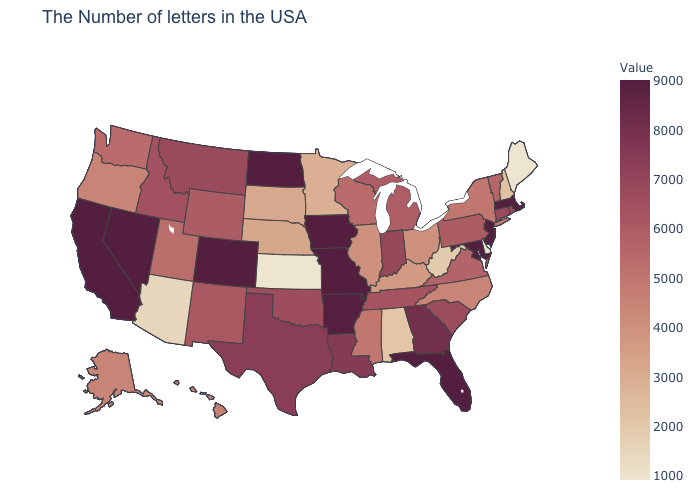Among the states that border Massachusetts , which have the lowest value?
Quick response, please. New Hampshire. Does Maine have the lowest value in the Northeast?
Be succinct. Yes. Is the legend a continuous bar?
Answer briefly. Yes. Which states have the highest value in the USA?
Be succinct. New Jersey, Maryland, Florida, Missouri, Iowa, North Dakota, Colorado, Nevada, California. Among the states that border Vermont , does Massachusetts have the highest value?
Quick response, please. Yes. Among the states that border Arizona , which have the highest value?
Give a very brief answer. Colorado, Nevada, California. Does Maryland have the highest value in the USA?
Give a very brief answer. Yes. Which states hav the highest value in the West?
Give a very brief answer. Colorado, Nevada, California. Does Texas have a lower value than Washington?
Concise answer only. No. 